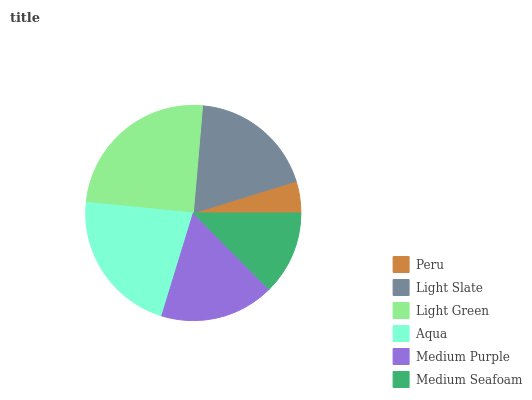Is Peru the minimum?
Answer yes or no. Yes. Is Light Green the maximum?
Answer yes or no. Yes. Is Light Slate the minimum?
Answer yes or no. No. Is Light Slate the maximum?
Answer yes or no. No. Is Light Slate greater than Peru?
Answer yes or no. Yes. Is Peru less than Light Slate?
Answer yes or no. Yes. Is Peru greater than Light Slate?
Answer yes or no. No. Is Light Slate less than Peru?
Answer yes or no. No. Is Light Slate the high median?
Answer yes or no. Yes. Is Medium Purple the low median?
Answer yes or no. Yes. Is Aqua the high median?
Answer yes or no. No. Is Light Slate the low median?
Answer yes or no. No. 